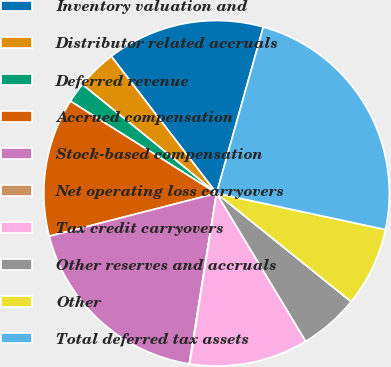<chart> <loc_0><loc_0><loc_500><loc_500><pie_chart><fcel>Inventory valuation and<fcel>Distributor related accruals<fcel>Deferred revenue<fcel>Accrued compensation<fcel>Stock-based compensation<fcel>Net operating loss carryovers<fcel>Tax credit carryovers<fcel>Other reserves and accruals<fcel>Other<fcel>Total deferred tax assets<nl><fcel>14.79%<fcel>3.73%<fcel>1.89%<fcel>12.95%<fcel>18.48%<fcel>0.05%<fcel>11.11%<fcel>5.58%<fcel>7.42%<fcel>24.01%<nl></chart> 